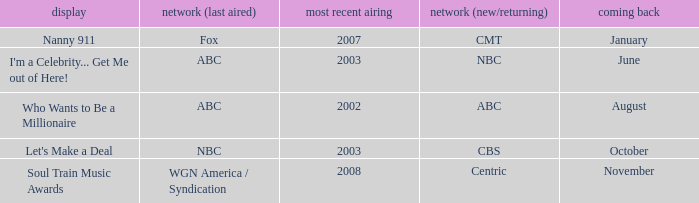What show was played on ABC laster after 2002? I'm a Celebrity... Get Me out of Here!. 